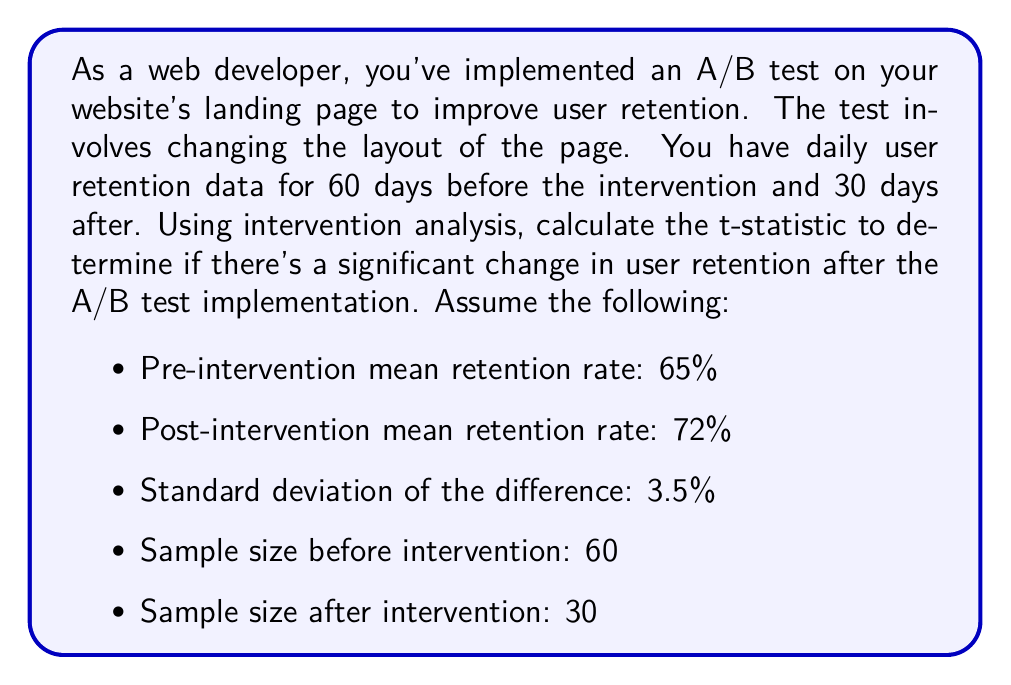Could you help me with this problem? To evaluate the impact of the A/B test on user retention using intervention analysis, we'll use a t-test for the difference in means before and after the intervention. The steps are as follows:

1. Calculate the pooled standard error:
   The pooled standard error (SE) is given by:
   
   $$ SE = s_d \sqrt{\frac{1}{n_1} + \frac{1}{n_2}} $$
   
   Where $s_d$ is the standard deviation of the difference, $n_1$ is the pre-intervention sample size, and $n_2$ is the post-intervention sample size.

   $$ SE = 3.5\% \sqrt{\frac{1}{60} + \frac{1}{30}} = 3.5\% \sqrt{0.0167 + 0.0333} = 3.5\% \sqrt{0.05} = 0.7826\% $$

2. Calculate the t-statistic:
   The t-statistic is given by:
   
   $$ t = \frac{\bar{X_2} - \bar{X_1}}{SE} $$
   
   Where $\bar{X_2}$ is the post-intervention mean and $\bar{X_1}$ is the pre-intervention mean.

   $$ t = \frac{72\% - 65\%}{0.7826\%} = \frac{7\%}{0.7826\%} = 8.94 $$

3. Interpret the result:
   The calculated t-statistic of 8.94 is relatively large, indicating a significant difference between the pre and post-intervention retention rates. To confirm statistical significance, you would compare this t-value to the critical t-value for your chosen significance level and degrees of freedom (df = $n_1 + n_2 - 2 = 88$).
Answer: The t-statistic for the intervention analysis is 8.94, suggesting a significant impact of the A/B test on user retention. 